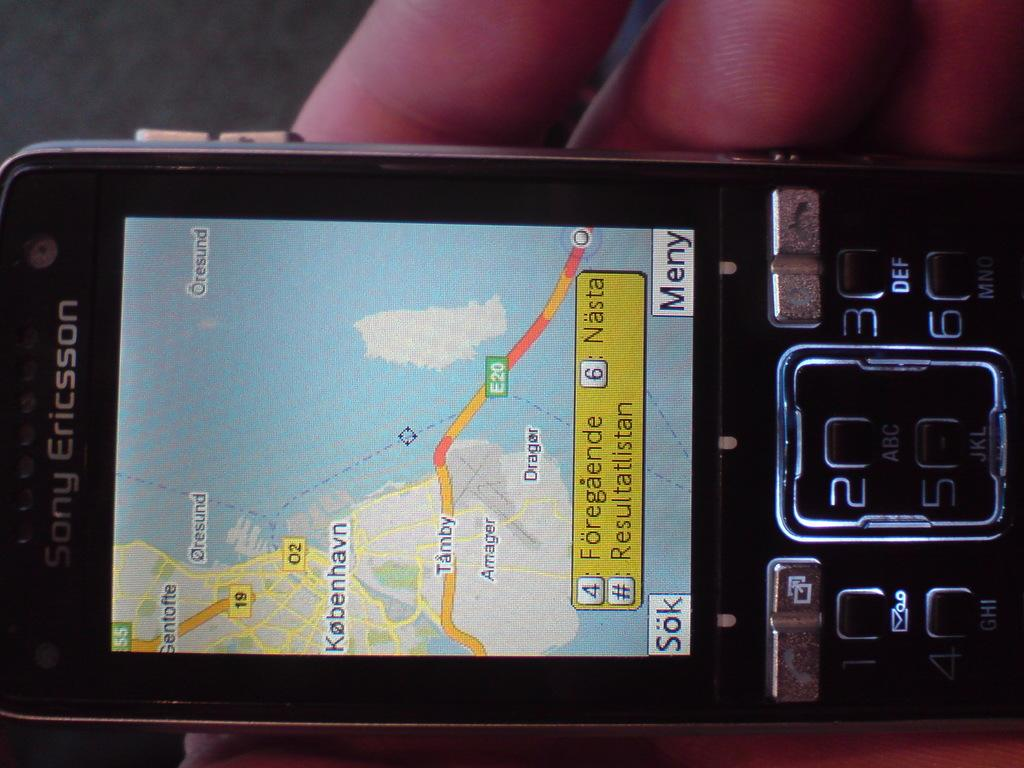Provide a one-sentence caption for the provided image. A map is displayed on a Sony Ericsson phone. 